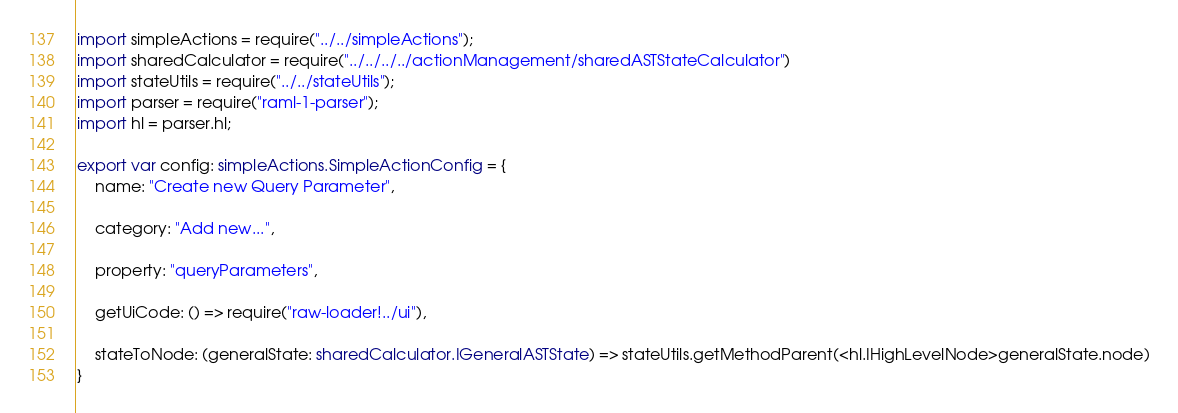<code> <loc_0><loc_0><loc_500><loc_500><_TypeScript_>import simpleActions = require("../../simpleActions");
import sharedCalculator = require("../../../../actionManagement/sharedASTStateCalculator")
import stateUtils = require("../../stateUtils");
import parser = require("raml-1-parser");
import hl = parser.hl;

export var config: simpleActions.SimpleActionConfig = {
    name: "Create new Query Parameter",

    category: "Add new...",

    property: "queryParameters",

    getUiCode: () => require("raw-loader!../ui"),

    stateToNode: (generalState: sharedCalculator.IGeneralASTState) => stateUtils.getMethodParent(<hl.IHighLevelNode>generalState.node)
}</code> 